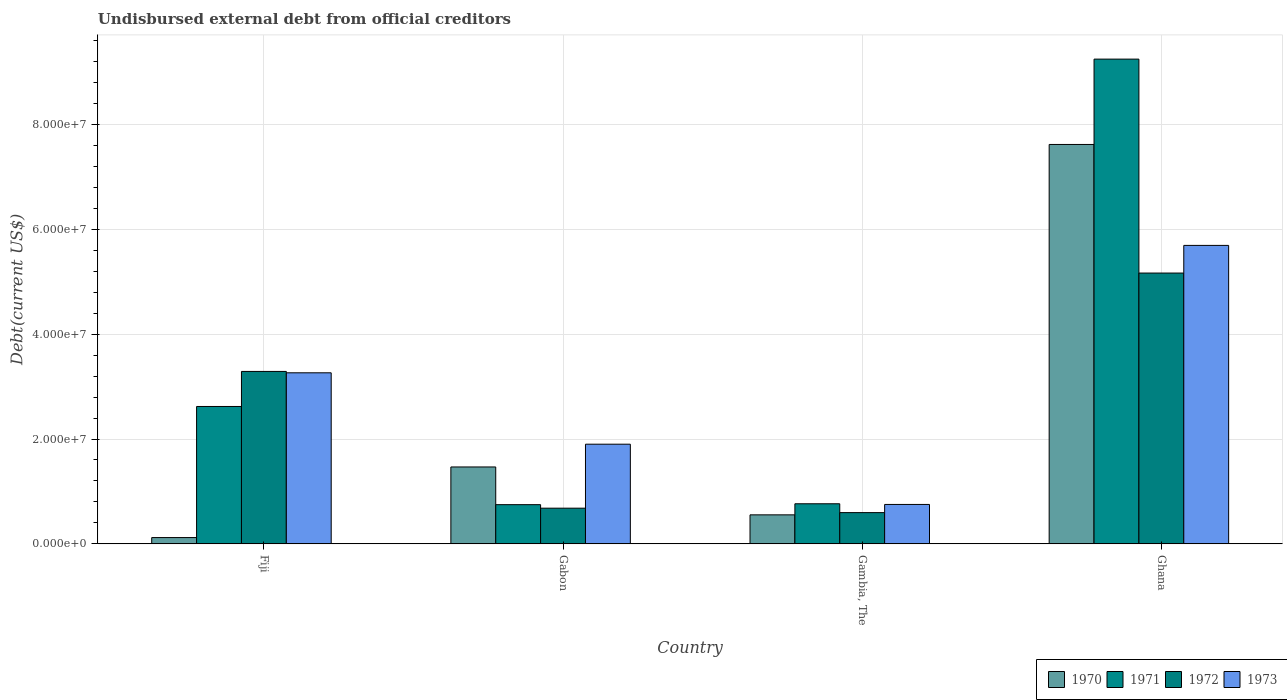How many different coloured bars are there?
Ensure brevity in your answer.  4. How many groups of bars are there?
Your answer should be very brief. 4. Are the number of bars per tick equal to the number of legend labels?
Offer a very short reply. Yes. Are the number of bars on each tick of the X-axis equal?
Offer a terse response. Yes. What is the label of the 3rd group of bars from the left?
Offer a terse response. Gambia, The. What is the total debt in 1972 in Gabon?
Your response must be concise. 6.81e+06. Across all countries, what is the maximum total debt in 1972?
Offer a terse response. 5.17e+07. Across all countries, what is the minimum total debt in 1972?
Provide a succinct answer. 5.96e+06. In which country was the total debt in 1972 minimum?
Ensure brevity in your answer.  Gambia, The. What is the total total debt in 1973 in the graph?
Ensure brevity in your answer.  1.16e+08. What is the difference between the total debt in 1970 in Gabon and that in Gambia, The?
Give a very brief answer. 9.14e+06. What is the difference between the total debt in 1973 in Gambia, The and the total debt in 1972 in Gabon?
Provide a short and direct response. 7.11e+05. What is the average total debt in 1970 per country?
Your answer should be compact. 2.44e+07. What is the difference between the total debt of/in 1973 and total debt of/in 1970 in Gambia, The?
Make the answer very short. 1.98e+06. In how many countries, is the total debt in 1973 greater than 92000000 US$?
Offer a very short reply. 0. What is the ratio of the total debt in 1973 in Fiji to that in Gambia, The?
Provide a succinct answer. 4.34. What is the difference between the highest and the second highest total debt in 1971?
Your answer should be compact. 6.63e+07. What is the difference between the highest and the lowest total debt in 1970?
Provide a short and direct response. 7.50e+07. In how many countries, is the total debt in 1970 greater than the average total debt in 1970 taken over all countries?
Provide a short and direct response. 1. What does the 4th bar from the left in Fiji represents?
Your answer should be compact. 1973. What does the 3rd bar from the right in Fiji represents?
Provide a short and direct response. 1971. Is it the case that in every country, the sum of the total debt in 1971 and total debt in 1970 is greater than the total debt in 1972?
Offer a very short reply. No. How many bars are there?
Give a very brief answer. 16. Are the values on the major ticks of Y-axis written in scientific E-notation?
Provide a short and direct response. Yes. Where does the legend appear in the graph?
Make the answer very short. Bottom right. How many legend labels are there?
Your answer should be compact. 4. What is the title of the graph?
Your answer should be compact. Undisbursed external debt from official creditors. What is the label or title of the Y-axis?
Offer a very short reply. Debt(current US$). What is the Debt(current US$) of 1970 in Fiji?
Offer a very short reply. 1.20e+06. What is the Debt(current US$) of 1971 in Fiji?
Offer a terse response. 2.62e+07. What is the Debt(current US$) in 1972 in Fiji?
Make the answer very short. 3.29e+07. What is the Debt(current US$) of 1973 in Fiji?
Keep it short and to the point. 3.26e+07. What is the Debt(current US$) of 1970 in Gabon?
Provide a short and direct response. 1.47e+07. What is the Debt(current US$) of 1971 in Gabon?
Offer a terse response. 7.48e+06. What is the Debt(current US$) in 1972 in Gabon?
Offer a terse response. 6.81e+06. What is the Debt(current US$) of 1973 in Gabon?
Provide a short and direct response. 1.90e+07. What is the Debt(current US$) in 1970 in Gambia, The?
Your response must be concise. 5.54e+06. What is the Debt(current US$) in 1971 in Gambia, The?
Keep it short and to the point. 7.65e+06. What is the Debt(current US$) in 1972 in Gambia, The?
Offer a terse response. 5.96e+06. What is the Debt(current US$) in 1973 in Gambia, The?
Offer a terse response. 7.52e+06. What is the Debt(current US$) of 1970 in Ghana?
Offer a terse response. 7.62e+07. What is the Debt(current US$) in 1971 in Ghana?
Make the answer very short. 9.25e+07. What is the Debt(current US$) of 1972 in Ghana?
Ensure brevity in your answer.  5.17e+07. What is the Debt(current US$) of 1973 in Ghana?
Ensure brevity in your answer.  5.69e+07. Across all countries, what is the maximum Debt(current US$) in 1970?
Make the answer very short. 7.62e+07. Across all countries, what is the maximum Debt(current US$) in 1971?
Make the answer very short. 9.25e+07. Across all countries, what is the maximum Debt(current US$) in 1972?
Your answer should be compact. 5.17e+07. Across all countries, what is the maximum Debt(current US$) in 1973?
Offer a very short reply. 5.69e+07. Across all countries, what is the minimum Debt(current US$) in 1970?
Give a very brief answer. 1.20e+06. Across all countries, what is the minimum Debt(current US$) in 1971?
Offer a terse response. 7.48e+06. Across all countries, what is the minimum Debt(current US$) of 1972?
Offer a terse response. 5.96e+06. Across all countries, what is the minimum Debt(current US$) in 1973?
Offer a terse response. 7.52e+06. What is the total Debt(current US$) in 1970 in the graph?
Keep it short and to the point. 9.76e+07. What is the total Debt(current US$) of 1971 in the graph?
Ensure brevity in your answer.  1.34e+08. What is the total Debt(current US$) in 1972 in the graph?
Ensure brevity in your answer.  9.73e+07. What is the total Debt(current US$) in 1973 in the graph?
Keep it short and to the point. 1.16e+08. What is the difference between the Debt(current US$) in 1970 in Fiji and that in Gabon?
Provide a succinct answer. -1.35e+07. What is the difference between the Debt(current US$) in 1971 in Fiji and that in Gabon?
Make the answer very short. 1.87e+07. What is the difference between the Debt(current US$) of 1972 in Fiji and that in Gabon?
Keep it short and to the point. 2.61e+07. What is the difference between the Debt(current US$) in 1973 in Fiji and that in Gabon?
Offer a terse response. 1.36e+07. What is the difference between the Debt(current US$) in 1970 in Fiji and that in Gambia, The?
Your answer should be compact. -4.34e+06. What is the difference between the Debt(current US$) of 1971 in Fiji and that in Gambia, The?
Provide a succinct answer. 1.86e+07. What is the difference between the Debt(current US$) of 1972 in Fiji and that in Gambia, The?
Give a very brief answer. 2.69e+07. What is the difference between the Debt(current US$) in 1973 in Fiji and that in Gambia, The?
Make the answer very short. 2.51e+07. What is the difference between the Debt(current US$) in 1970 in Fiji and that in Ghana?
Ensure brevity in your answer.  -7.50e+07. What is the difference between the Debt(current US$) of 1971 in Fiji and that in Ghana?
Provide a succinct answer. -6.63e+07. What is the difference between the Debt(current US$) of 1972 in Fiji and that in Ghana?
Give a very brief answer. -1.88e+07. What is the difference between the Debt(current US$) of 1973 in Fiji and that in Ghana?
Your answer should be compact. -2.43e+07. What is the difference between the Debt(current US$) in 1970 in Gabon and that in Gambia, The?
Keep it short and to the point. 9.14e+06. What is the difference between the Debt(current US$) of 1971 in Gabon and that in Gambia, The?
Give a very brief answer. -1.71e+05. What is the difference between the Debt(current US$) of 1972 in Gabon and that in Gambia, The?
Keep it short and to the point. 8.46e+05. What is the difference between the Debt(current US$) in 1973 in Gabon and that in Gambia, The?
Your response must be concise. 1.15e+07. What is the difference between the Debt(current US$) in 1970 in Gabon and that in Ghana?
Give a very brief answer. -6.15e+07. What is the difference between the Debt(current US$) of 1971 in Gabon and that in Ghana?
Offer a very short reply. -8.50e+07. What is the difference between the Debt(current US$) in 1972 in Gabon and that in Ghana?
Offer a very short reply. -4.49e+07. What is the difference between the Debt(current US$) of 1973 in Gabon and that in Ghana?
Offer a terse response. -3.79e+07. What is the difference between the Debt(current US$) of 1970 in Gambia, The and that in Ghana?
Offer a terse response. -7.07e+07. What is the difference between the Debt(current US$) in 1971 in Gambia, The and that in Ghana?
Provide a succinct answer. -8.48e+07. What is the difference between the Debt(current US$) in 1972 in Gambia, The and that in Ghana?
Ensure brevity in your answer.  -4.57e+07. What is the difference between the Debt(current US$) in 1973 in Gambia, The and that in Ghana?
Ensure brevity in your answer.  -4.94e+07. What is the difference between the Debt(current US$) in 1970 in Fiji and the Debt(current US$) in 1971 in Gabon?
Your response must be concise. -6.28e+06. What is the difference between the Debt(current US$) in 1970 in Fiji and the Debt(current US$) in 1972 in Gabon?
Make the answer very short. -5.61e+06. What is the difference between the Debt(current US$) in 1970 in Fiji and the Debt(current US$) in 1973 in Gabon?
Offer a terse response. -1.78e+07. What is the difference between the Debt(current US$) in 1971 in Fiji and the Debt(current US$) in 1972 in Gabon?
Keep it short and to the point. 1.94e+07. What is the difference between the Debt(current US$) of 1971 in Fiji and the Debt(current US$) of 1973 in Gabon?
Provide a succinct answer. 7.19e+06. What is the difference between the Debt(current US$) in 1972 in Fiji and the Debt(current US$) in 1973 in Gabon?
Your answer should be very brief. 1.39e+07. What is the difference between the Debt(current US$) of 1970 in Fiji and the Debt(current US$) of 1971 in Gambia, The?
Offer a very short reply. -6.45e+06. What is the difference between the Debt(current US$) of 1970 in Fiji and the Debt(current US$) of 1972 in Gambia, The?
Your response must be concise. -4.76e+06. What is the difference between the Debt(current US$) of 1970 in Fiji and the Debt(current US$) of 1973 in Gambia, The?
Your response must be concise. -6.32e+06. What is the difference between the Debt(current US$) in 1971 in Fiji and the Debt(current US$) in 1972 in Gambia, The?
Provide a succinct answer. 2.02e+07. What is the difference between the Debt(current US$) in 1971 in Fiji and the Debt(current US$) in 1973 in Gambia, The?
Offer a very short reply. 1.87e+07. What is the difference between the Debt(current US$) in 1972 in Fiji and the Debt(current US$) in 1973 in Gambia, The?
Your response must be concise. 2.54e+07. What is the difference between the Debt(current US$) in 1970 in Fiji and the Debt(current US$) in 1971 in Ghana?
Your response must be concise. -9.13e+07. What is the difference between the Debt(current US$) of 1970 in Fiji and the Debt(current US$) of 1972 in Ghana?
Your answer should be very brief. -5.05e+07. What is the difference between the Debt(current US$) of 1970 in Fiji and the Debt(current US$) of 1973 in Ghana?
Offer a terse response. -5.57e+07. What is the difference between the Debt(current US$) of 1971 in Fiji and the Debt(current US$) of 1972 in Ghana?
Give a very brief answer. -2.55e+07. What is the difference between the Debt(current US$) of 1971 in Fiji and the Debt(current US$) of 1973 in Ghana?
Keep it short and to the point. -3.07e+07. What is the difference between the Debt(current US$) of 1972 in Fiji and the Debt(current US$) of 1973 in Ghana?
Keep it short and to the point. -2.40e+07. What is the difference between the Debt(current US$) in 1970 in Gabon and the Debt(current US$) in 1971 in Gambia, The?
Make the answer very short. 7.02e+06. What is the difference between the Debt(current US$) of 1970 in Gabon and the Debt(current US$) of 1972 in Gambia, The?
Offer a very short reply. 8.71e+06. What is the difference between the Debt(current US$) of 1970 in Gabon and the Debt(current US$) of 1973 in Gambia, The?
Make the answer very short. 7.15e+06. What is the difference between the Debt(current US$) of 1971 in Gabon and the Debt(current US$) of 1972 in Gambia, The?
Make the answer very short. 1.52e+06. What is the difference between the Debt(current US$) of 1971 in Gabon and the Debt(current US$) of 1973 in Gambia, The?
Provide a succinct answer. -4.10e+04. What is the difference between the Debt(current US$) in 1972 in Gabon and the Debt(current US$) in 1973 in Gambia, The?
Provide a short and direct response. -7.11e+05. What is the difference between the Debt(current US$) of 1970 in Gabon and the Debt(current US$) of 1971 in Ghana?
Keep it short and to the point. -7.78e+07. What is the difference between the Debt(current US$) in 1970 in Gabon and the Debt(current US$) in 1972 in Ghana?
Ensure brevity in your answer.  -3.70e+07. What is the difference between the Debt(current US$) in 1970 in Gabon and the Debt(current US$) in 1973 in Ghana?
Offer a very short reply. -4.23e+07. What is the difference between the Debt(current US$) in 1971 in Gabon and the Debt(current US$) in 1972 in Ghana?
Ensure brevity in your answer.  -4.42e+07. What is the difference between the Debt(current US$) of 1971 in Gabon and the Debt(current US$) of 1973 in Ghana?
Keep it short and to the point. -4.95e+07. What is the difference between the Debt(current US$) in 1972 in Gabon and the Debt(current US$) in 1973 in Ghana?
Your answer should be very brief. -5.01e+07. What is the difference between the Debt(current US$) of 1970 in Gambia, The and the Debt(current US$) of 1971 in Ghana?
Provide a short and direct response. -8.69e+07. What is the difference between the Debt(current US$) of 1970 in Gambia, The and the Debt(current US$) of 1972 in Ghana?
Ensure brevity in your answer.  -4.61e+07. What is the difference between the Debt(current US$) in 1970 in Gambia, The and the Debt(current US$) in 1973 in Ghana?
Ensure brevity in your answer.  -5.14e+07. What is the difference between the Debt(current US$) in 1971 in Gambia, The and the Debt(current US$) in 1972 in Ghana?
Your response must be concise. -4.40e+07. What is the difference between the Debt(current US$) of 1971 in Gambia, The and the Debt(current US$) of 1973 in Ghana?
Give a very brief answer. -4.93e+07. What is the difference between the Debt(current US$) of 1972 in Gambia, The and the Debt(current US$) of 1973 in Ghana?
Your response must be concise. -5.10e+07. What is the average Debt(current US$) in 1970 per country?
Give a very brief answer. 2.44e+07. What is the average Debt(current US$) of 1971 per country?
Offer a very short reply. 3.35e+07. What is the average Debt(current US$) of 1972 per country?
Ensure brevity in your answer.  2.43e+07. What is the average Debt(current US$) of 1973 per country?
Offer a terse response. 2.90e+07. What is the difference between the Debt(current US$) of 1970 and Debt(current US$) of 1971 in Fiji?
Offer a very short reply. -2.50e+07. What is the difference between the Debt(current US$) in 1970 and Debt(current US$) in 1972 in Fiji?
Provide a succinct answer. -3.17e+07. What is the difference between the Debt(current US$) of 1970 and Debt(current US$) of 1973 in Fiji?
Ensure brevity in your answer.  -3.14e+07. What is the difference between the Debt(current US$) in 1971 and Debt(current US$) in 1972 in Fiji?
Provide a short and direct response. -6.68e+06. What is the difference between the Debt(current US$) in 1971 and Debt(current US$) in 1973 in Fiji?
Offer a terse response. -6.42e+06. What is the difference between the Debt(current US$) in 1972 and Debt(current US$) in 1973 in Fiji?
Ensure brevity in your answer.  2.61e+05. What is the difference between the Debt(current US$) in 1970 and Debt(current US$) in 1971 in Gabon?
Provide a short and direct response. 7.19e+06. What is the difference between the Debt(current US$) of 1970 and Debt(current US$) of 1972 in Gabon?
Your answer should be compact. 7.86e+06. What is the difference between the Debt(current US$) in 1970 and Debt(current US$) in 1973 in Gabon?
Make the answer very short. -4.34e+06. What is the difference between the Debt(current US$) of 1971 and Debt(current US$) of 1972 in Gabon?
Offer a terse response. 6.70e+05. What is the difference between the Debt(current US$) in 1971 and Debt(current US$) in 1973 in Gabon?
Your response must be concise. -1.15e+07. What is the difference between the Debt(current US$) in 1972 and Debt(current US$) in 1973 in Gabon?
Offer a terse response. -1.22e+07. What is the difference between the Debt(current US$) in 1970 and Debt(current US$) in 1971 in Gambia, The?
Your response must be concise. -2.11e+06. What is the difference between the Debt(current US$) in 1970 and Debt(current US$) in 1972 in Gambia, The?
Your response must be concise. -4.26e+05. What is the difference between the Debt(current US$) in 1970 and Debt(current US$) in 1973 in Gambia, The?
Give a very brief answer. -1.98e+06. What is the difference between the Debt(current US$) of 1971 and Debt(current US$) of 1972 in Gambia, The?
Provide a short and direct response. 1.69e+06. What is the difference between the Debt(current US$) of 1972 and Debt(current US$) of 1973 in Gambia, The?
Your response must be concise. -1.56e+06. What is the difference between the Debt(current US$) in 1970 and Debt(current US$) in 1971 in Ghana?
Ensure brevity in your answer.  -1.63e+07. What is the difference between the Debt(current US$) of 1970 and Debt(current US$) of 1972 in Ghana?
Keep it short and to the point. 2.45e+07. What is the difference between the Debt(current US$) in 1970 and Debt(current US$) in 1973 in Ghana?
Keep it short and to the point. 1.93e+07. What is the difference between the Debt(current US$) of 1971 and Debt(current US$) of 1972 in Ghana?
Your response must be concise. 4.08e+07. What is the difference between the Debt(current US$) in 1971 and Debt(current US$) in 1973 in Ghana?
Provide a succinct answer. 3.55e+07. What is the difference between the Debt(current US$) in 1972 and Debt(current US$) in 1973 in Ghana?
Your response must be concise. -5.28e+06. What is the ratio of the Debt(current US$) of 1970 in Fiji to that in Gabon?
Make the answer very short. 0.08. What is the ratio of the Debt(current US$) in 1971 in Fiji to that in Gabon?
Give a very brief answer. 3.5. What is the ratio of the Debt(current US$) in 1972 in Fiji to that in Gabon?
Offer a terse response. 4.83. What is the ratio of the Debt(current US$) in 1973 in Fiji to that in Gabon?
Provide a short and direct response. 1.72. What is the ratio of the Debt(current US$) in 1970 in Fiji to that in Gambia, The?
Keep it short and to the point. 0.22. What is the ratio of the Debt(current US$) of 1971 in Fiji to that in Gambia, The?
Keep it short and to the point. 3.43. What is the ratio of the Debt(current US$) of 1972 in Fiji to that in Gambia, The?
Keep it short and to the point. 5.52. What is the ratio of the Debt(current US$) in 1973 in Fiji to that in Gambia, The?
Provide a short and direct response. 4.34. What is the ratio of the Debt(current US$) of 1970 in Fiji to that in Ghana?
Give a very brief answer. 0.02. What is the ratio of the Debt(current US$) in 1971 in Fiji to that in Ghana?
Provide a short and direct response. 0.28. What is the ratio of the Debt(current US$) in 1972 in Fiji to that in Ghana?
Provide a succinct answer. 0.64. What is the ratio of the Debt(current US$) of 1973 in Fiji to that in Ghana?
Make the answer very short. 0.57. What is the ratio of the Debt(current US$) of 1970 in Gabon to that in Gambia, The?
Ensure brevity in your answer.  2.65. What is the ratio of the Debt(current US$) in 1971 in Gabon to that in Gambia, The?
Provide a succinct answer. 0.98. What is the ratio of the Debt(current US$) in 1972 in Gabon to that in Gambia, The?
Make the answer very short. 1.14. What is the ratio of the Debt(current US$) in 1973 in Gabon to that in Gambia, The?
Your response must be concise. 2.53. What is the ratio of the Debt(current US$) of 1970 in Gabon to that in Ghana?
Keep it short and to the point. 0.19. What is the ratio of the Debt(current US$) in 1971 in Gabon to that in Ghana?
Keep it short and to the point. 0.08. What is the ratio of the Debt(current US$) in 1972 in Gabon to that in Ghana?
Your response must be concise. 0.13. What is the ratio of the Debt(current US$) in 1973 in Gabon to that in Ghana?
Offer a terse response. 0.33. What is the ratio of the Debt(current US$) of 1970 in Gambia, The to that in Ghana?
Your response must be concise. 0.07. What is the ratio of the Debt(current US$) in 1971 in Gambia, The to that in Ghana?
Give a very brief answer. 0.08. What is the ratio of the Debt(current US$) of 1972 in Gambia, The to that in Ghana?
Ensure brevity in your answer.  0.12. What is the ratio of the Debt(current US$) in 1973 in Gambia, The to that in Ghana?
Offer a terse response. 0.13. What is the difference between the highest and the second highest Debt(current US$) of 1970?
Offer a very short reply. 6.15e+07. What is the difference between the highest and the second highest Debt(current US$) of 1971?
Provide a short and direct response. 6.63e+07. What is the difference between the highest and the second highest Debt(current US$) of 1972?
Provide a succinct answer. 1.88e+07. What is the difference between the highest and the second highest Debt(current US$) in 1973?
Make the answer very short. 2.43e+07. What is the difference between the highest and the lowest Debt(current US$) of 1970?
Your answer should be compact. 7.50e+07. What is the difference between the highest and the lowest Debt(current US$) of 1971?
Your response must be concise. 8.50e+07. What is the difference between the highest and the lowest Debt(current US$) in 1972?
Your answer should be very brief. 4.57e+07. What is the difference between the highest and the lowest Debt(current US$) in 1973?
Your answer should be compact. 4.94e+07. 